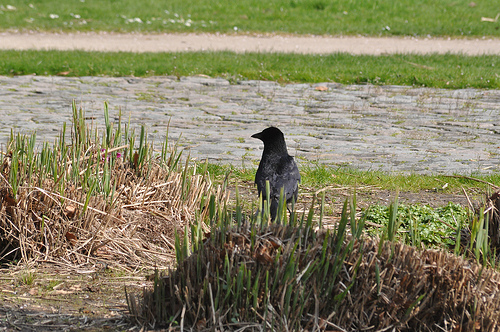<image>
Can you confirm if the bird is in the water? No. The bird is not contained within the water. These objects have a different spatial relationship. 